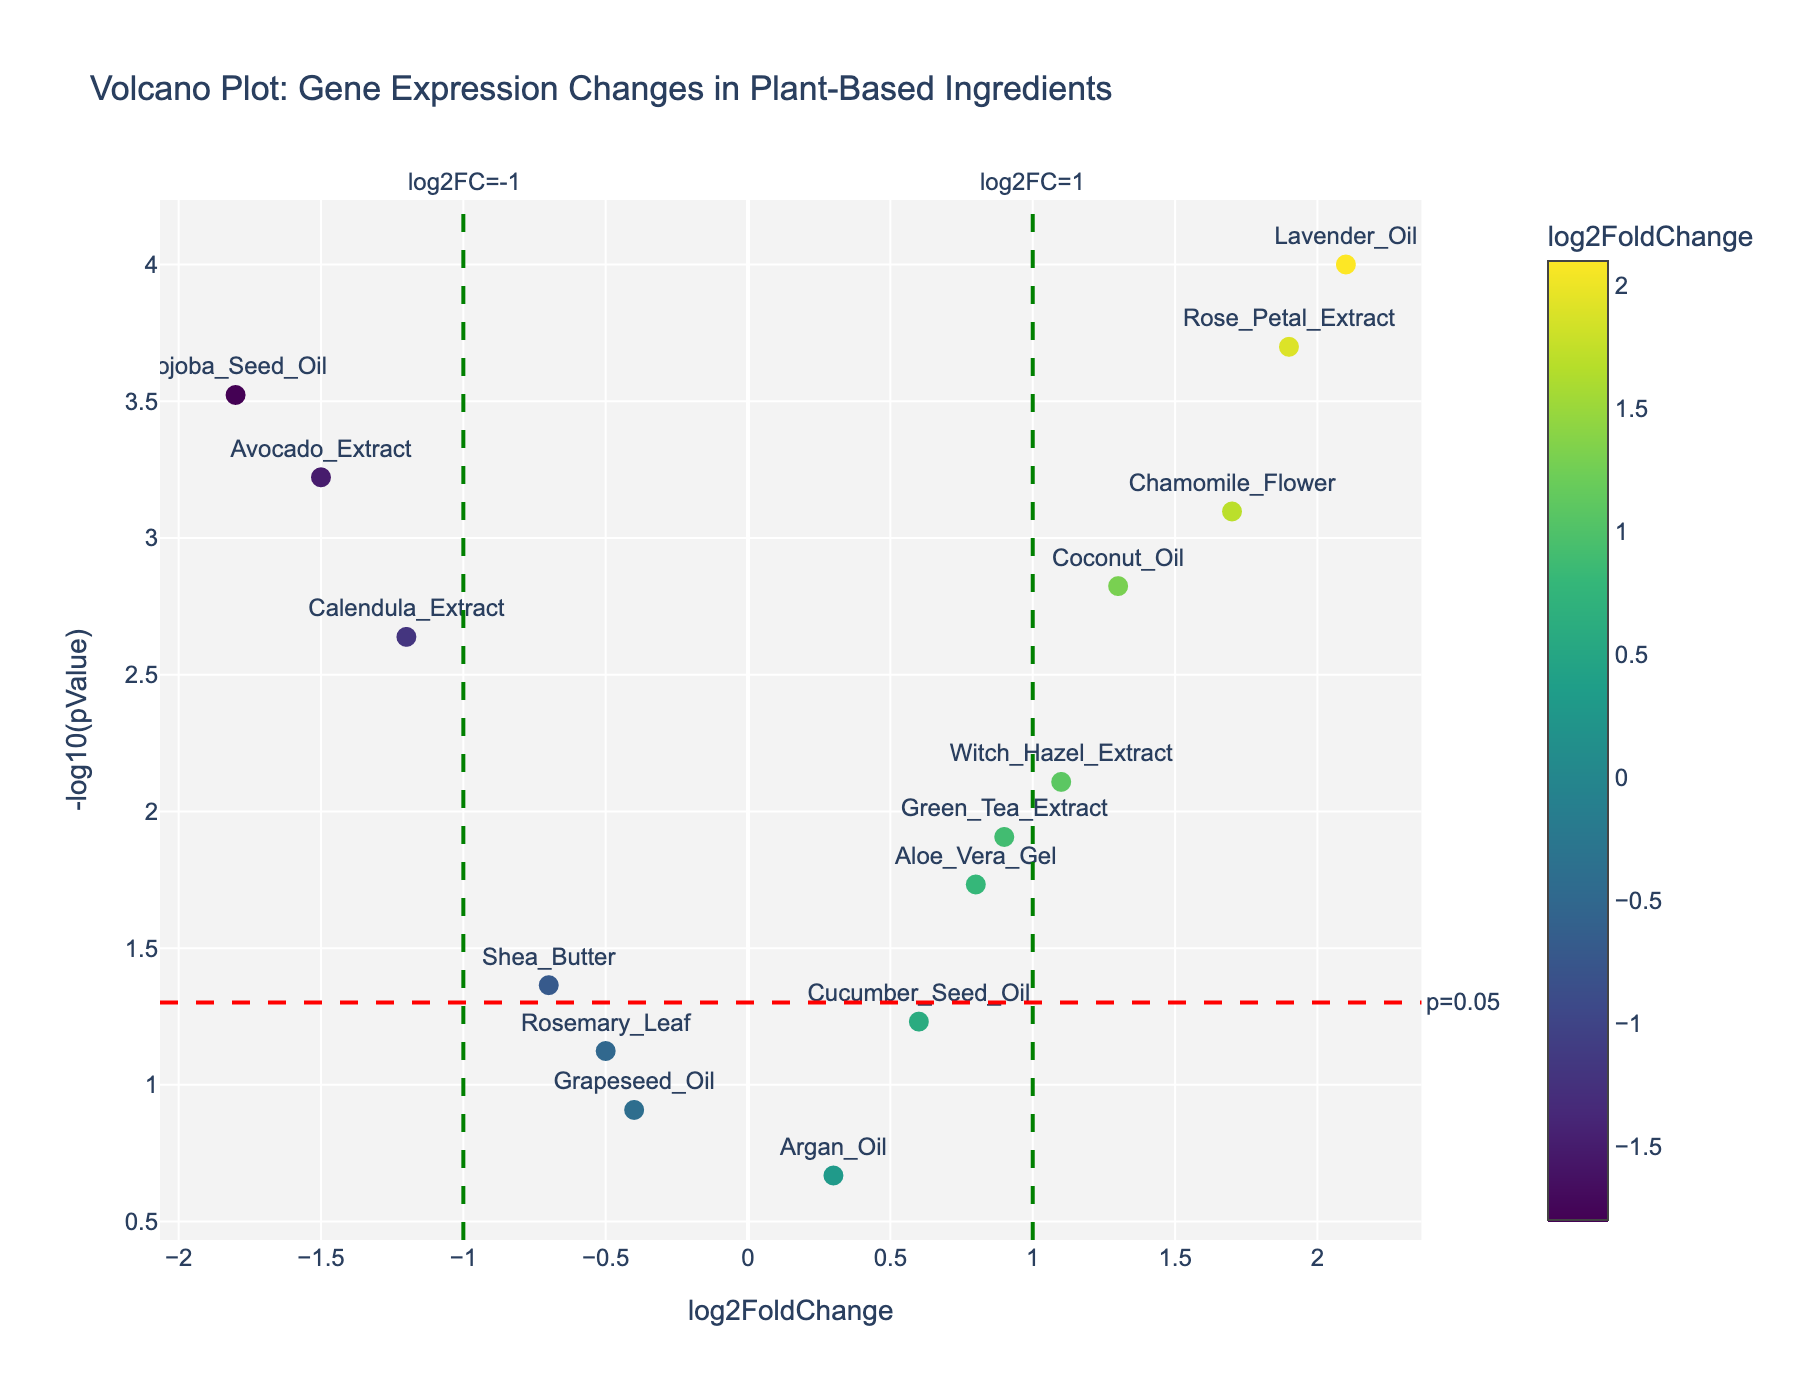What's the title of the plot? The title of the plot is located at the top of the figure and summarizes the chart purpose. In this case, it reads "Volcano Plot: Gene Expression Changes in Plant-Based Ingredients".
Answer: Volcano Plot: Gene Expression Changes in Plant-Based Ingredients What does the x-axis represent? The label on the x-axis indicates it represents 'log2FoldChange'. This measures the logarithm base 2 of the fold change in gene expression.
Answer: log2FoldChange What does the y-axis represent? The label on the y-axis indicates it represents '-log10(pValue)'. This measures the negative logarithm base 10 of the p-value.
Answer: -log10(pValue) How many data points are there in the plot? Each marker represents a gene, and by counting the labeled markers, there are 15 data points.
Answer: 15 Which gene has the highest log2FoldChange? By looking at the x-axis, the gene with the highest log2FoldChange is located at the far right. This marker has the label 'Lavender_Oil' with a log2FoldChange of 2.1.
Answer: Lavender_Oil How many genes have a p-value less than 0.05? The red dashed line represents the p-value threshold of 0.05. Count the markers that are above this line, as these have a -log10(pValue) greater than -log10(0.05). There are 11 such genes.
Answer: 11 Which gene has the lowest log2FoldChange and a significant p-value? The marker with the lowest log2FoldChange below -1 on the x-axis and above the p-value threshold line is identified. 'Jojoba_Seed_Oil' has the lowest log2FoldChange of -1.8 with a significant p-value.
Answer: Jojoba_Seed_Oil How is the color of the markers determined? The dots are colored according to their log2FoldChange values, with a colorbar on the right side indicating this relation using the Viridis colorscale.
Answer: By log2FoldChange values Which genes have a log2FoldChange between -1 and 1 and a p-value less than 0.05? Looking between -1 and 1 on the x-axis, count all genes above the dashed red line. The genes are 'Aloe_Vera_Gel', 'Green_Tea_Extract', 'Shea_Butter', and 'Witch_Hazel_Extract'.
Answer: Aloe_Vera_Gel, Green_Tea_Extract, Shea_Butter, Witch_Hazel_Extract Which gene has a p-value closest to 0.05? Find the marker closest to the horizontal dashed red line, representing -log10(0.05). It is the 'Shea_Butter' gene as it is on the lower edge of significant p-values.
Answer: Shea_Butter 